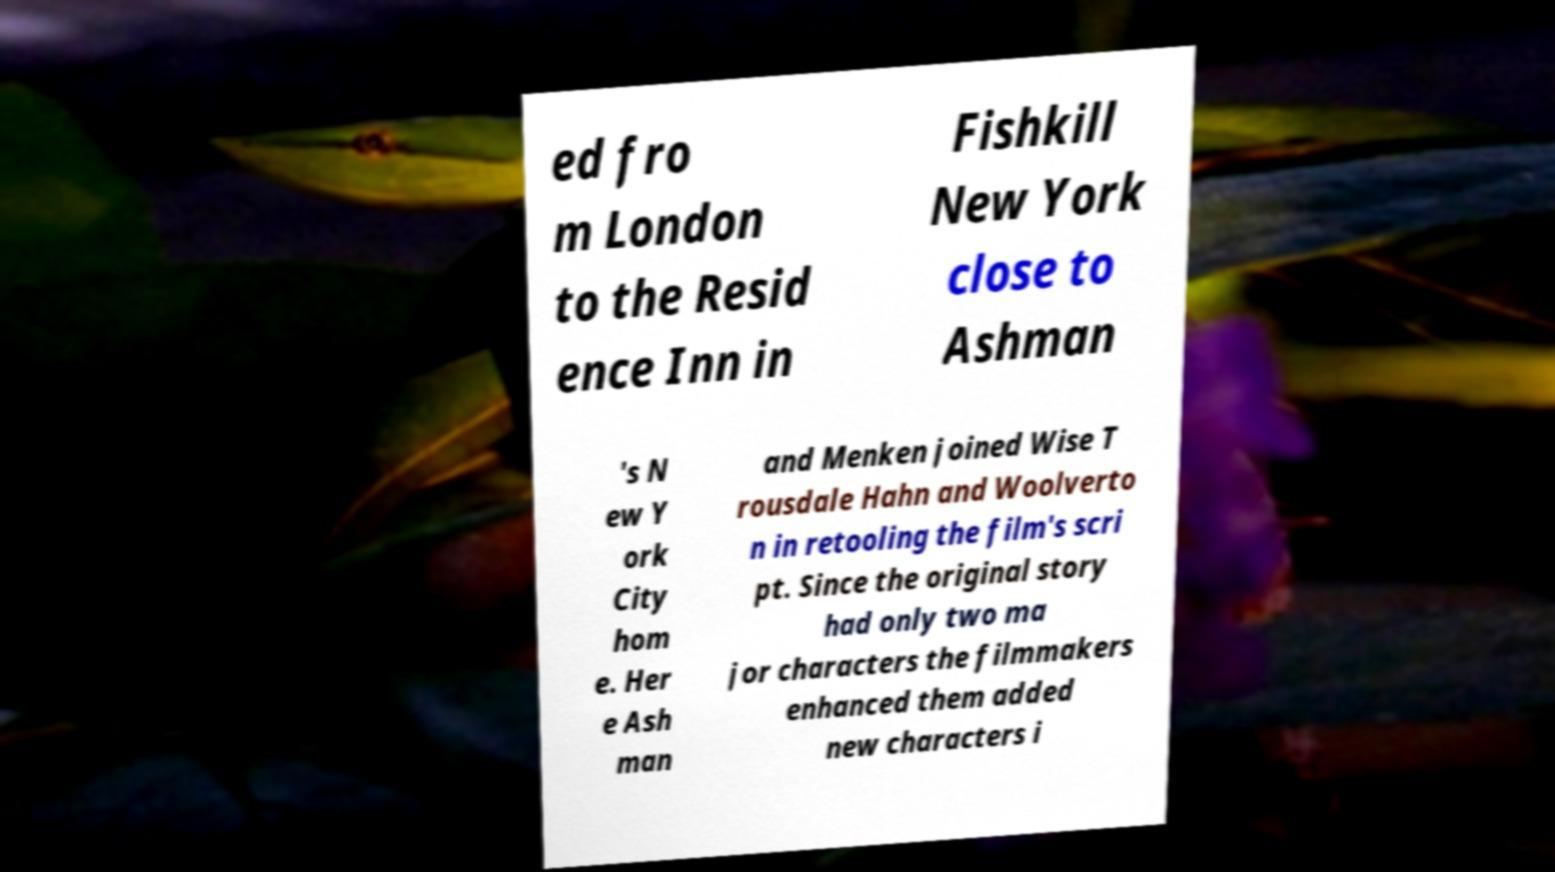There's text embedded in this image that I need extracted. Can you transcribe it verbatim? ed fro m London to the Resid ence Inn in Fishkill New York close to Ashman 's N ew Y ork City hom e. Her e Ash man and Menken joined Wise T rousdale Hahn and Woolverto n in retooling the film's scri pt. Since the original story had only two ma jor characters the filmmakers enhanced them added new characters i 